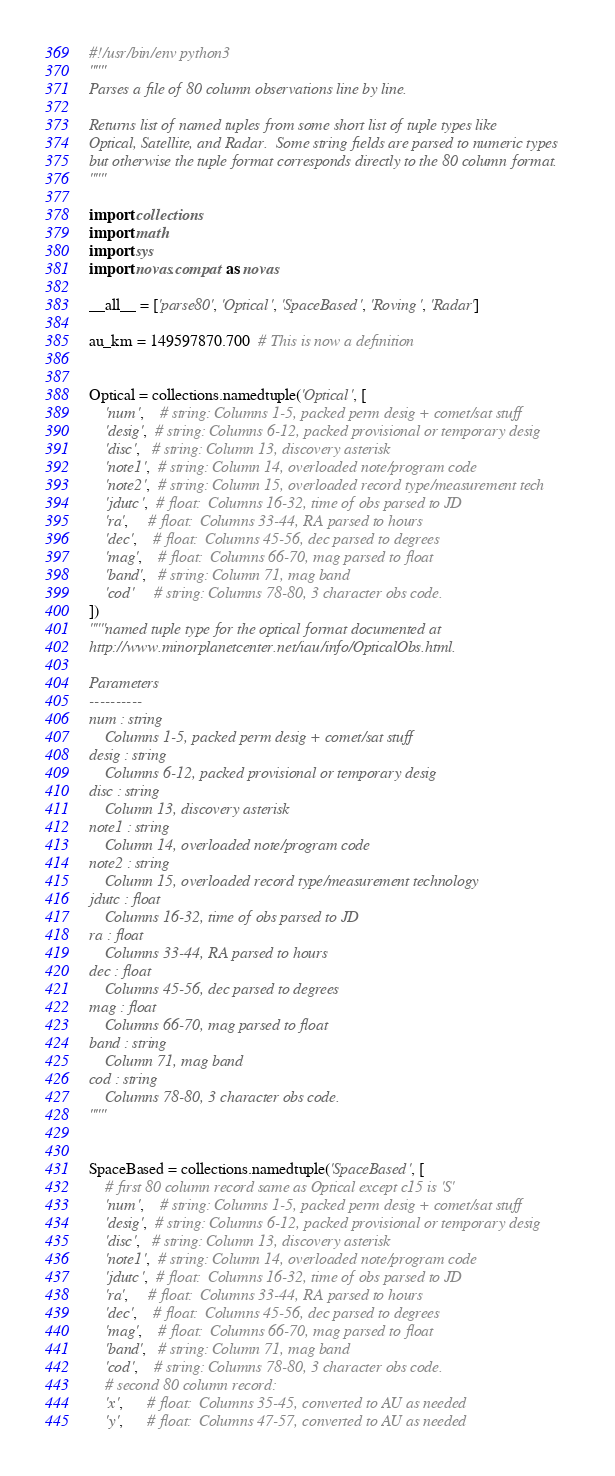Convert code to text. <code><loc_0><loc_0><loc_500><loc_500><_Python_>#!/usr/bin/env python3
"""
Parses a file of 80 column observations line by line.

Returns list of named tuples from some short list of tuple types like
Optical, Satellite, and Radar.  Some string fields are parsed to numeric types
but otherwise the tuple format corresponds directly to the 80 column format.
"""

import collections
import math
import sys
import novas.compat as novas

__all__ = ['parse80', 'Optical', 'SpaceBased', 'Roving', 'Radar']

au_km = 149597870.700  # This is now a definition


Optical = collections.namedtuple('Optical', [
    'num',    # string: Columns 1-5, packed perm desig + comet/sat stuff
    'desig',  # string: Columns 6-12, packed provisional or temporary desig
    'disc',   # string: Column 13, discovery asterisk
    'note1',  # string: Column 14, overloaded note/program code
    'note2',  # string: Column 15, overloaded record type/measurement tech
    'jdutc',  # float:  Columns 16-32, time of obs parsed to JD
    'ra',     # float:  Columns 33-44, RA parsed to hours
    'dec',    # float:  Columns 45-56, dec parsed to degrees
    'mag',    # float:  Columns 66-70, mag parsed to float
    'band',   # string: Column 71, mag band
    'cod'     # string: Columns 78-80, 3 character obs code.
])
"""named tuple type for the optical format documented at
http://www.minorplanetcenter.net/iau/info/OpticalObs.html.

Parameters
----------
num : string
    Columns 1-5, packed perm desig + comet/sat stuff
desig : string
    Columns 6-12, packed provisional or temporary desig
disc : string
    Column 13, discovery asterisk
note1 : string
    Column 14, overloaded note/program code
note2 : string
    Column 15, overloaded record type/measurement technology
jdutc : float
    Columns 16-32, time of obs parsed to JD
ra : float
    Columns 33-44, RA parsed to hours
dec : float
    Columns 45-56, dec parsed to degrees
mag : float
    Columns 66-70, mag parsed to float
band : string
    Column 71, mag band
cod : string
    Columns 78-80, 3 character obs code.
"""


SpaceBased = collections.namedtuple('SpaceBased', [
    # first 80 column record same as Optical except c15 is 'S'
    'num',    # string: Columns 1-5, packed perm desig + comet/sat stuff
    'desig',  # string: Columns 6-12, packed provisional or temporary desig
    'disc',   # string: Column 13, discovery asterisk
    'note1',  # string: Column 14, overloaded note/program code
    'jdutc',  # float:  Columns 16-32, time of obs parsed to JD
    'ra',     # float:  Columns 33-44, RA parsed to hours
    'dec',    # float:  Columns 45-56, dec parsed to degrees
    'mag',    # float:  Columns 66-70, mag parsed to float
    'band',   # string: Column 71, mag band
    'cod',    # string: Columns 78-80, 3 character obs code.
    # second 80 column record:
    'x',      # float:  Columns 35-45, converted to AU as needed
    'y',      # float:  Columns 47-57, converted to AU as needed</code> 